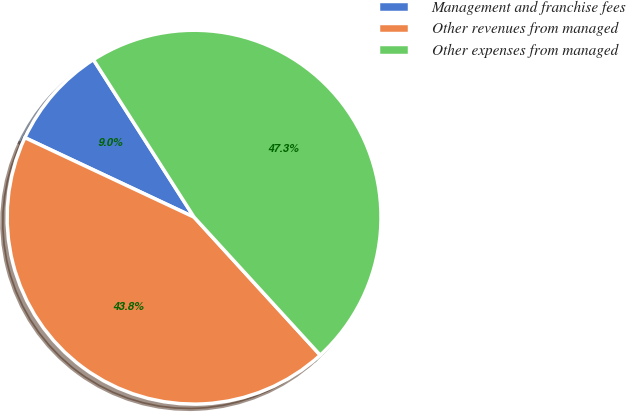Convert chart. <chart><loc_0><loc_0><loc_500><loc_500><pie_chart><fcel>Management and franchise fees<fcel>Other revenues from managed<fcel>Other expenses from managed<nl><fcel>8.96%<fcel>43.78%<fcel>47.26%<nl></chart> 